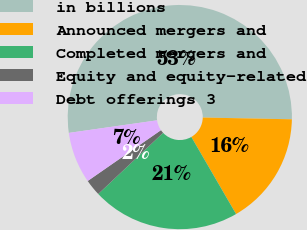Convert chart. <chart><loc_0><loc_0><loc_500><loc_500><pie_chart><fcel>in billions<fcel>Announced mergers and<fcel>Completed mergers and<fcel>Equity and equity-related<fcel>Debt offerings 3<nl><fcel>52.57%<fcel>16.32%<fcel>21.34%<fcel>2.38%<fcel>7.4%<nl></chart> 